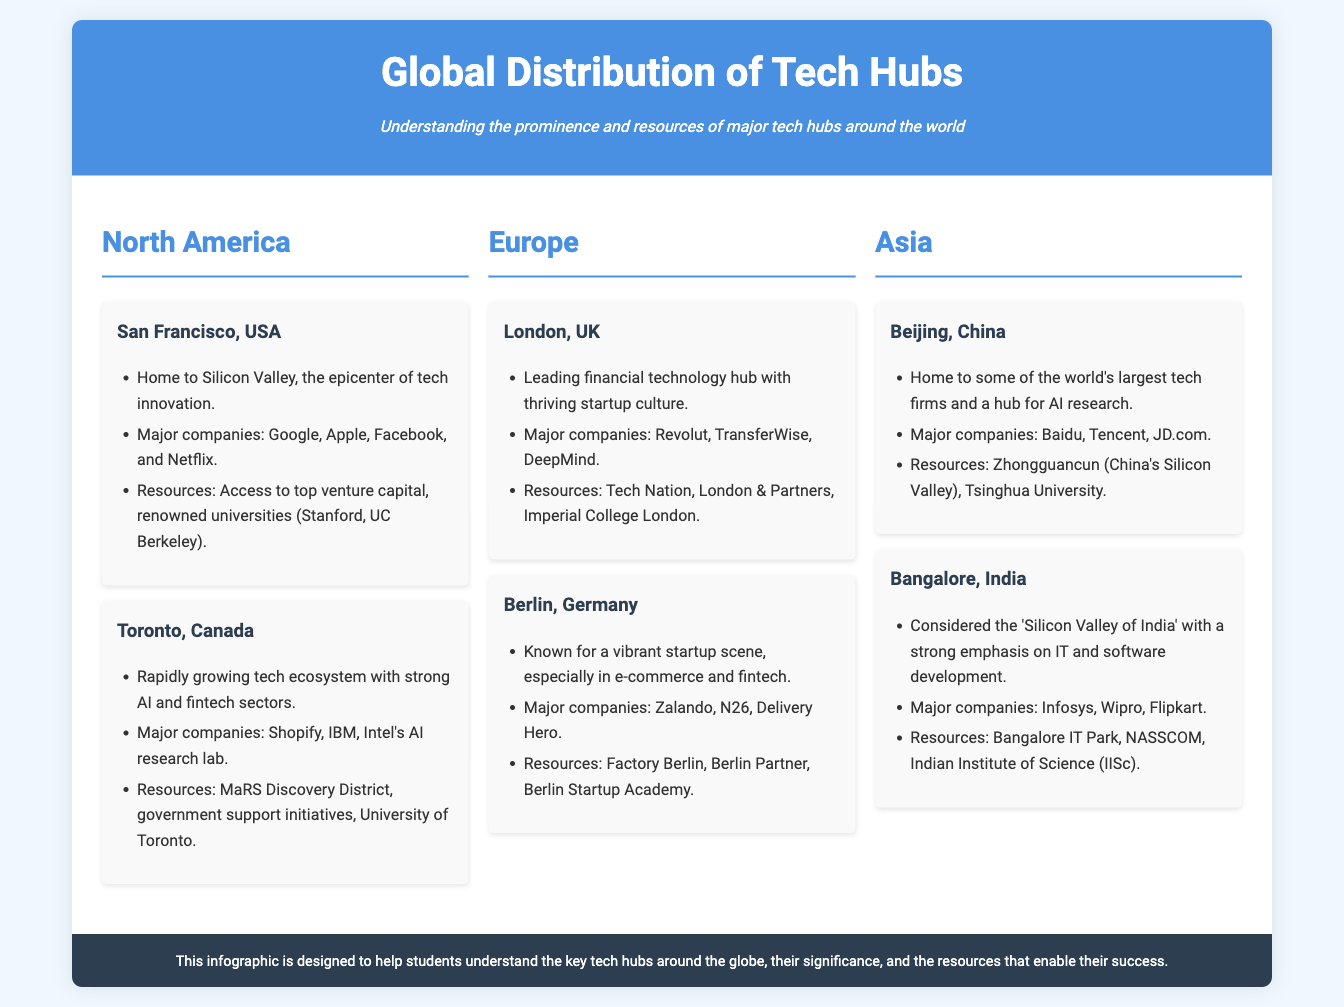What city is known as the epicenter of tech innovation? The document states that San Francisco, USA, is home to Silicon Valley, the epicenter of tech innovation.
Answer: San Francisco Which major company is associated with Toronto, Canada? The document lists Shopify, IBM, and Intel's AI research lab as major companies in Toronto.
Answer: Shopify What is the primary resource for startups in Berlin, Germany? The text mentions Factory Berlin as a key resource for startups.
Answer: Factory Berlin Which city is referred to as the 'Silicon Valley of India'? The document describes Bangalore, India, as the 'Silicon Valley of India'.
Answer: Bangalore What sector is London, UK, leading in? The document highlights London as a leading financial technology hub.
Answer: Financial technology What significant university is mentioned for San Francisco's tech ecosystem? The document lists Stanford University as a significant resource in San Francisco.
Answer: Stanford University What two companies are major players in Beijing, China? The main companies mentioned in the document are Baidu and Tencent.
Answer: Baidu, Tencent Which city is noted for a strong emphasis on AI and fintech? Toronto, Canada, is described as having a strong focus on AI and fintech sectors.
Answer: Toronto What unique feature does Bengaluru, India, have in the context of technology? The document notes that Bengaluru is known for a strong emphasis on IT and software development.
Answer: IT and software development 